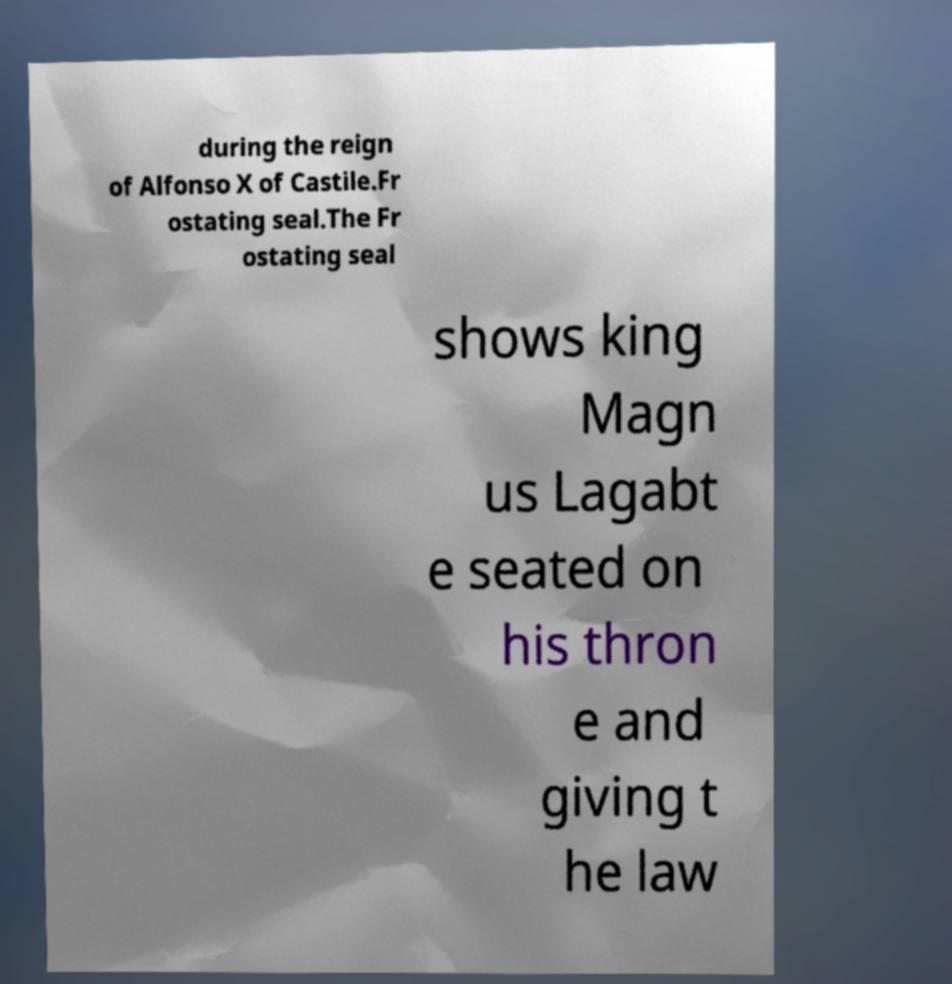For documentation purposes, I need the text within this image transcribed. Could you provide that? during the reign of Alfonso X of Castile.Fr ostating seal.The Fr ostating seal shows king Magn us Lagabt e seated on his thron e and giving t he law 